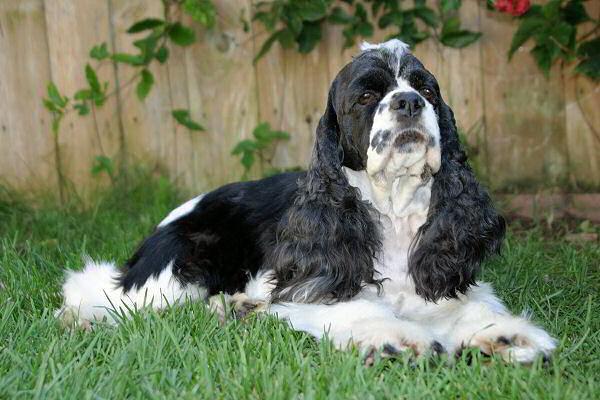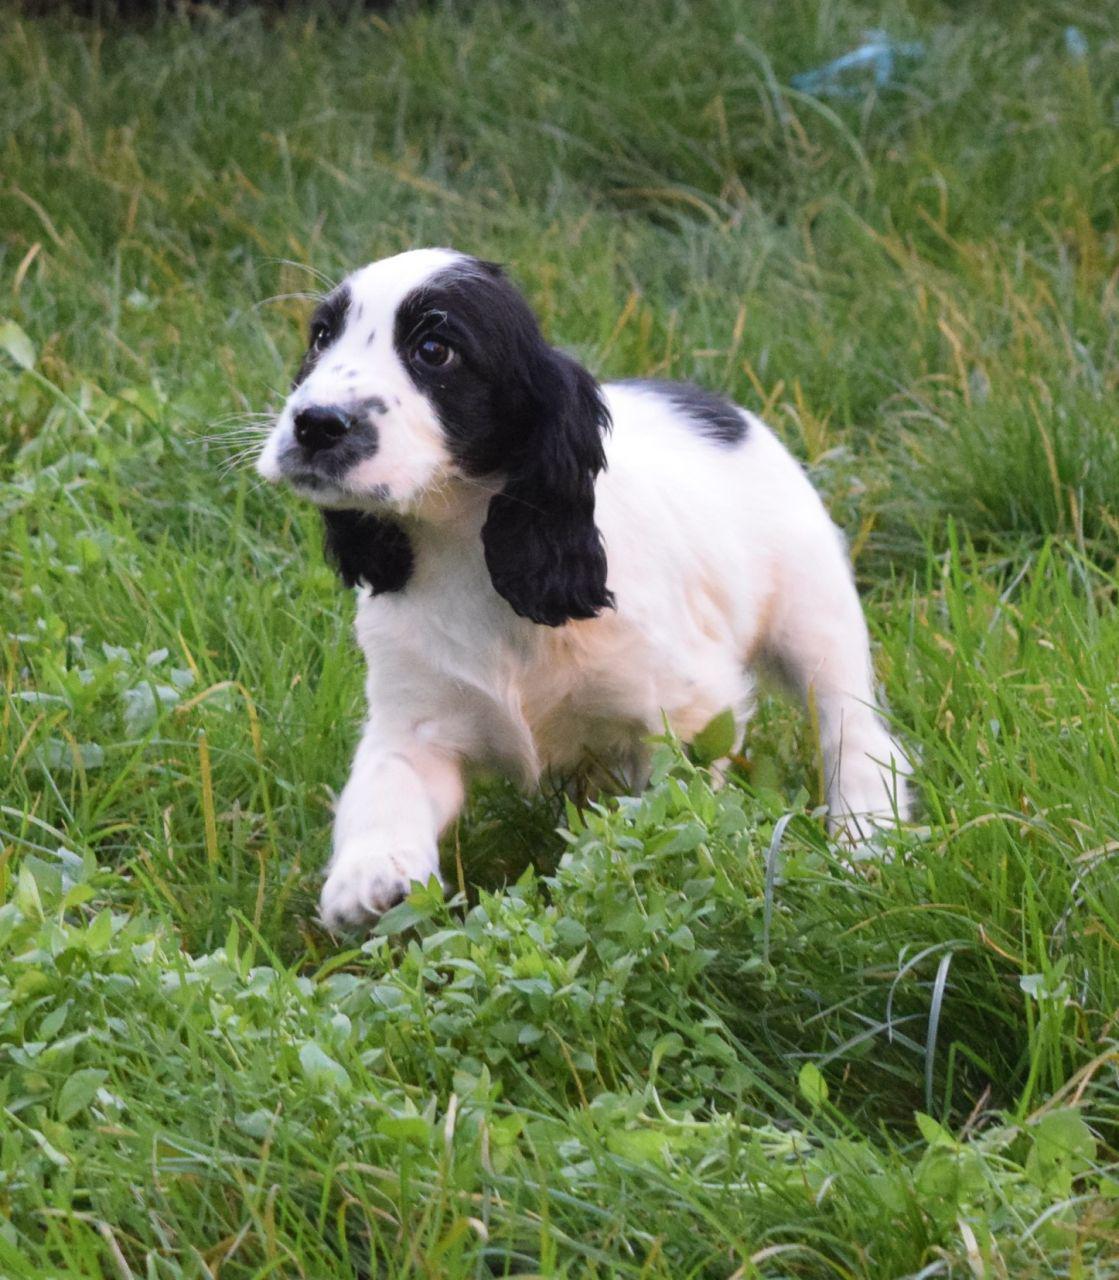The first image is the image on the left, the second image is the image on the right. Analyze the images presented: Is the assertion "Two out of the three dogs have some black fur." valid? Answer yes or no. No. The first image is the image on the left, the second image is the image on the right. Assess this claim about the two images: "One image shows a spaniel with a white muzzle and black fur on eye and ear areas, and the other image shows two different colored spaniels posed close together.". Correct or not? Answer yes or no. No. 